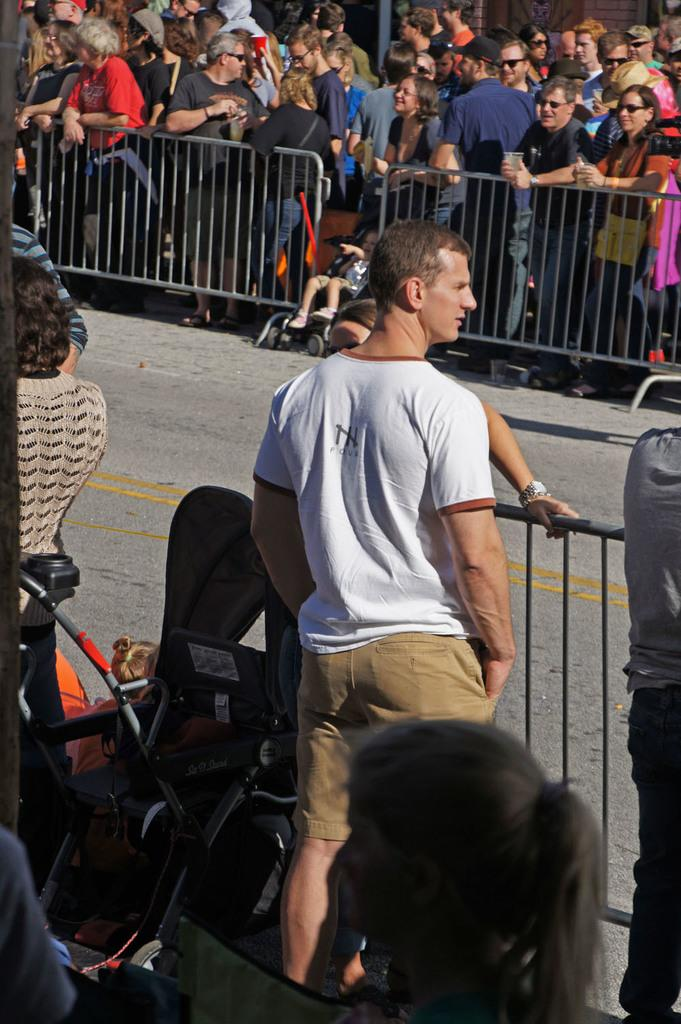What is the main subject of the image? There is a man standing in the image. What object can be seen near the man? There is a black color baby trolley in the image. What type of environment is depicted in the image? There is a road and a fence in the image. Are there any other people in the image besides the man? Yes, there are people standing in the image. What type of shop can be seen in the background of the image? There is no shop visible in the image. What story is the man telling the people in the image? The image does not provide any information about a story being told. 